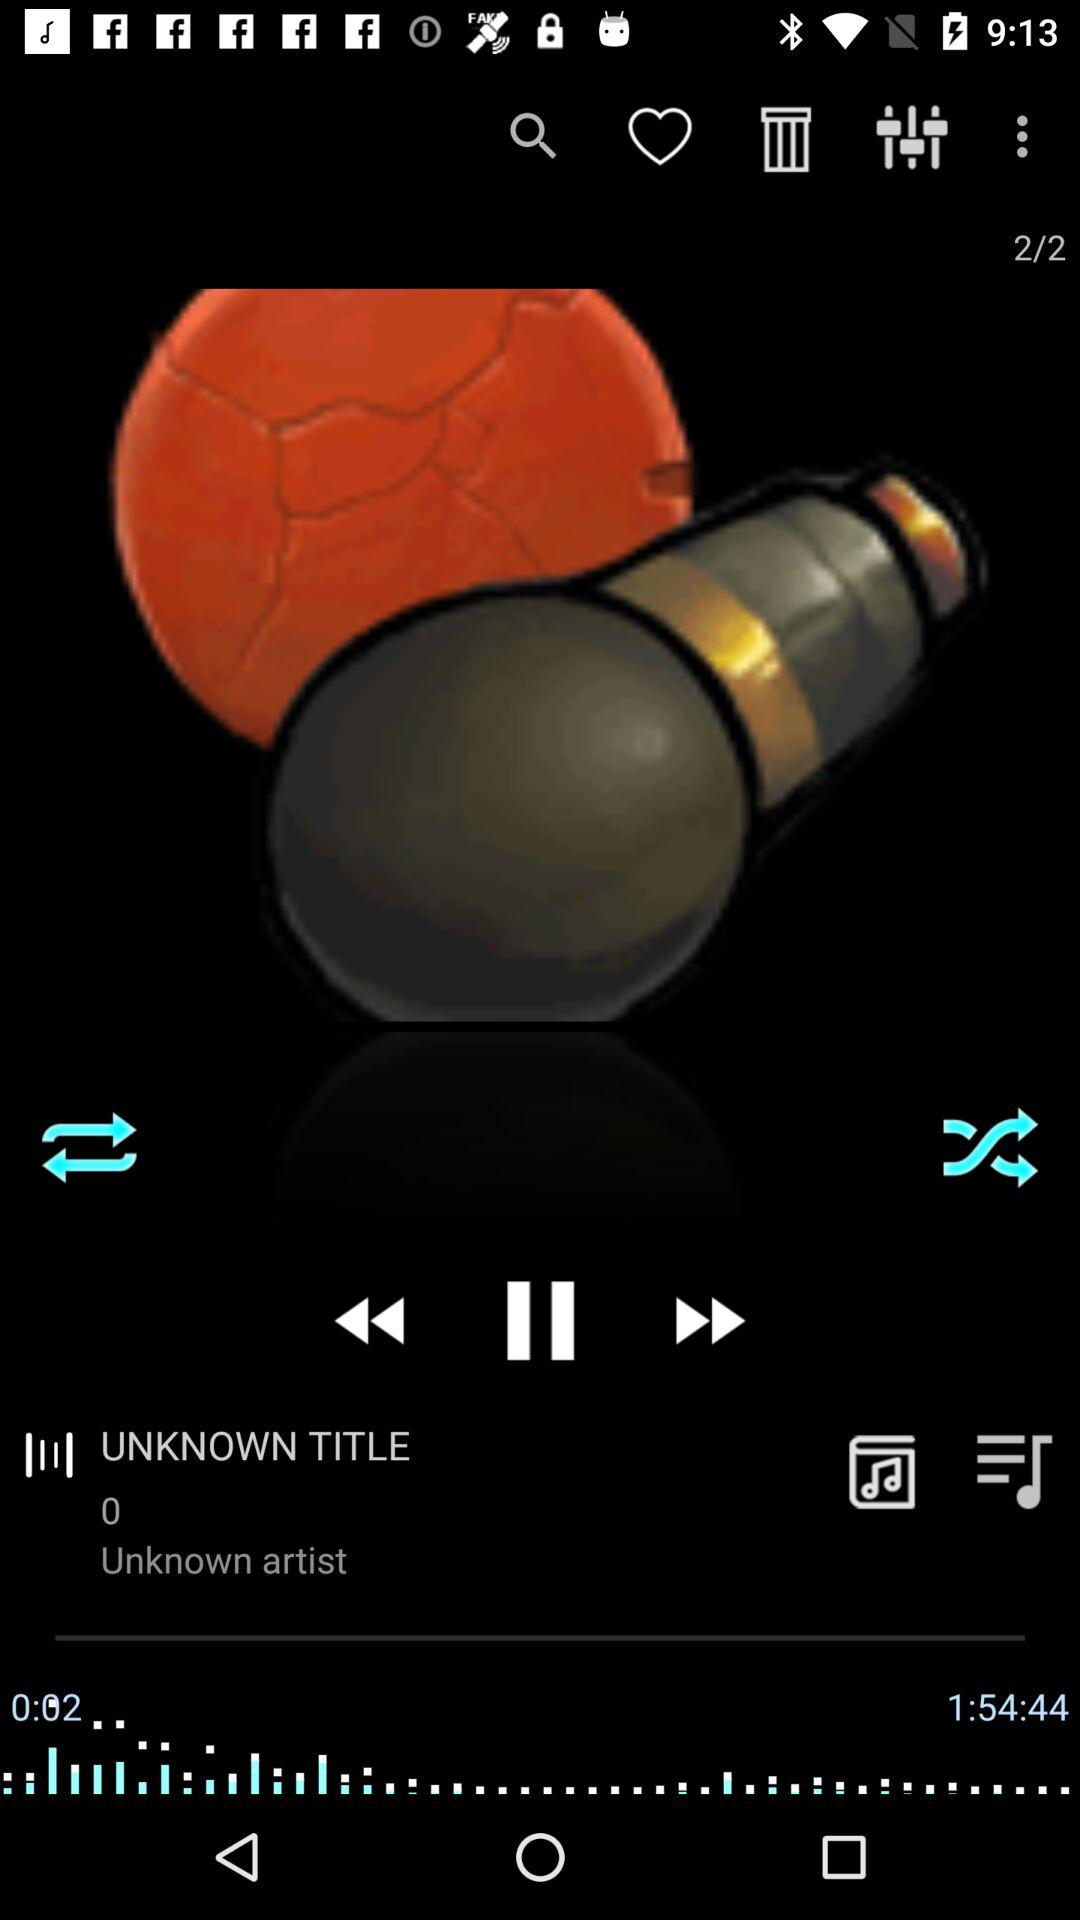How many pages are there? There are 2 pages. 